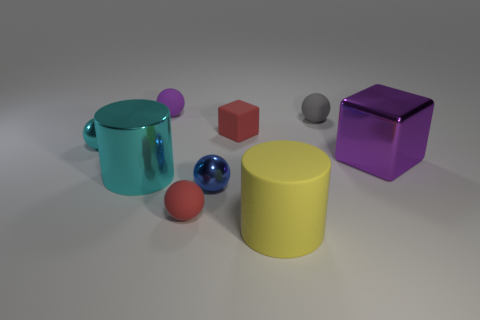Subtract all purple spheres. How many spheres are left? 4 Subtract all gray matte spheres. How many spheres are left? 4 Subtract all green spheres. Subtract all yellow cubes. How many spheres are left? 5 Subtract all balls. How many objects are left? 4 Add 4 yellow rubber cylinders. How many yellow rubber cylinders are left? 5 Add 3 tiny purple objects. How many tiny purple objects exist? 4 Subtract 1 cyan cylinders. How many objects are left? 8 Subtract all big yellow rubber cylinders. Subtract all large matte cylinders. How many objects are left? 7 